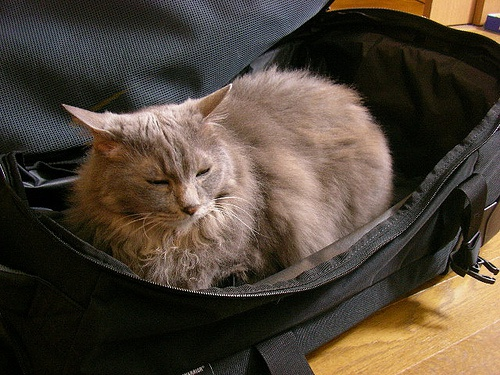Describe the objects in this image and their specific colors. I can see suitcase in black and gray tones and cat in black, gray, darkgray, maroon, and tan tones in this image. 